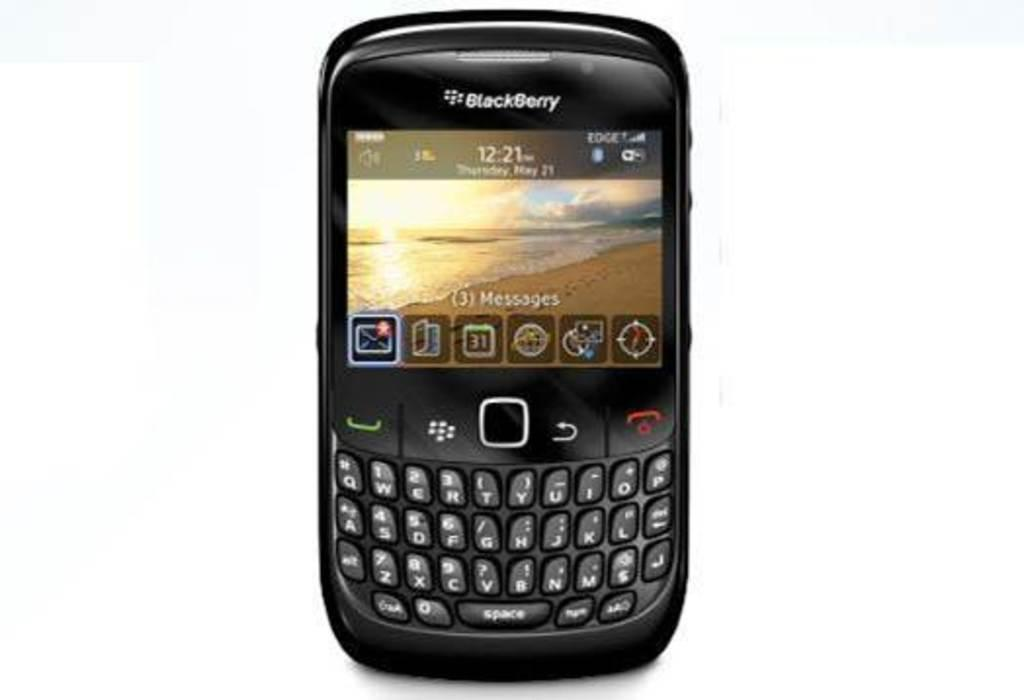Provide a one-sentence caption for the provided image. A Blackberry phone has a sunset on the screen, above the keys with letters and numbers on them. 